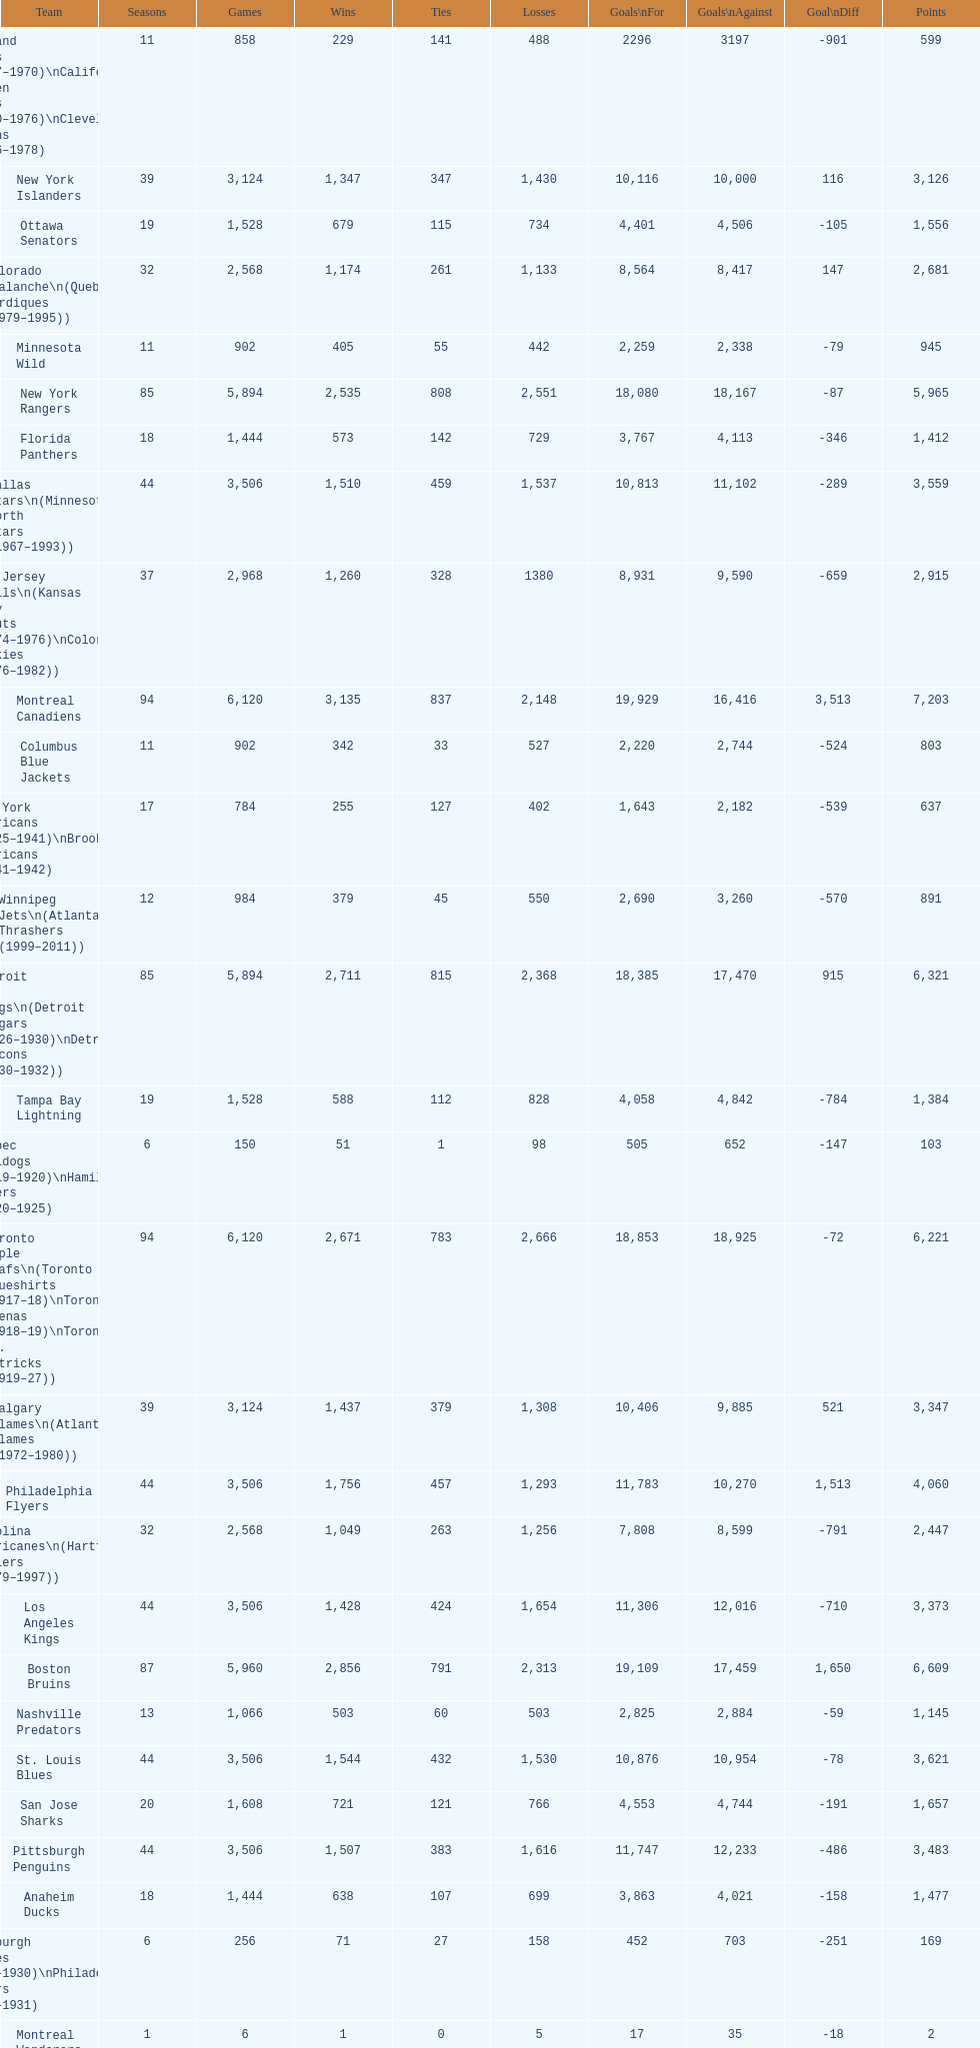How many losses do the st. louis blues have? 1,530. 